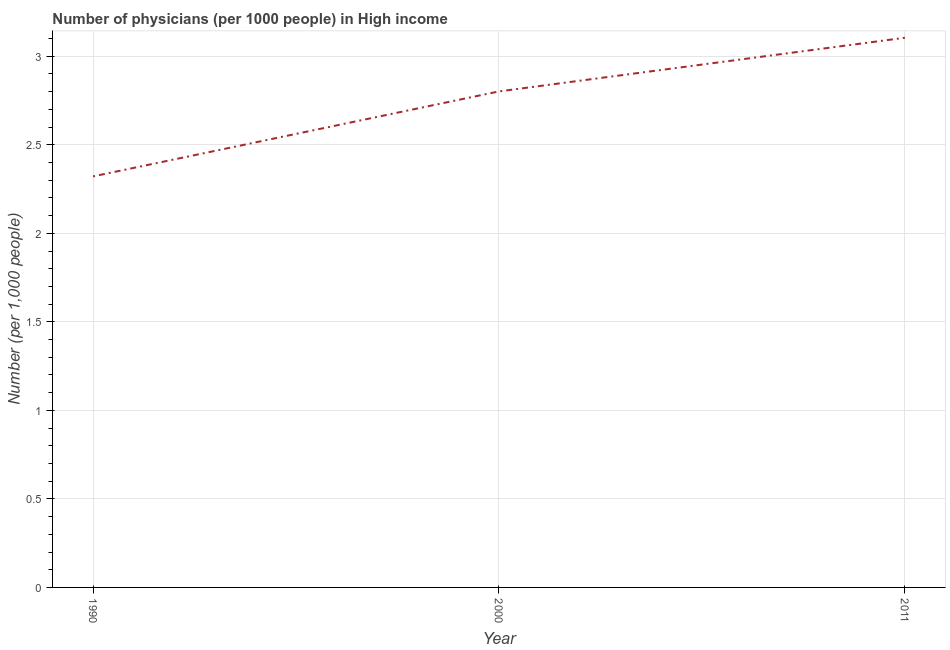What is the number of physicians in 1990?
Make the answer very short. 2.32. Across all years, what is the maximum number of physicians?
Ensure brevity in your answer.  3.1. Across all years, what is the minimum number of physicians?
Give a very brief answer. 2.32. In which year was the number of physicians maximum?
Your response must be concise. 2011. In which year was the number of physicians minimum?
Provide a succinct answer. 1990. What is the sum of the number of physicians?
Your answer should be very brief. 8.23. What is the difference between the number of physicians in 2000 and 2011?
Your answer should be compact. -0.3. What is the average number of physicians per year?
Offer a very short reply. 2.74. What is the median number of physicians?
Provide a short and direct response. 2.8. What is the ratio of the number of physicians in 1990 to that in 2011?
Give a very brief answer. 0.75. Is the difference between the number of physicians in 2000 and 2011 greater than the difference between any two years?
Your answer should be compact. No. What is the difference between the highest and the second highest number of physicians?
Keep it short and to the point. 0.3. What is the difference between the highest and the lowest number of physicians?
Offer a terse response. 0.78. How many lines are there?
Give a very brief answer. 1. What is the title of the graph?
Offer a very short reply. Number of physicians (per 1000 people) in High income. What is the label or title of the Y-axis?
Provide a short and direct response. Number (per 1,0 people). What is the Number (per 1,000 people) of 1990?
Keep it short and to the point. 2.32. What is the Number (per 1,000 people) in 2000?
Your answer should be very brief. 2.8. What is the Number (per 1,000 people) in 2011?
Offer a very short reply. 3.1. What is the difference between the Number (per 1,000 people) in 1990 and 2000?
Provide a succinct answer. -0.48. What is the difference between the Number (per 1,000 people) in 1990 and 2011?
Make the answer very short. -0.78. What is the difference between the Number (per 1,000 people) in 2000 and 2011?
Provide a short and direct response. -0.3. What is the ratio of the Number (per 1,000 people) in 1990 to that in 2000?
Give a very brief answer. 0.83. What is the ratio of the Number (per 1,000 people) in 1990 to that in 2011?
Give a very brief answer. 0.75. What is the ratio of the Number (per 1,000 people) in 2000 to that in 2011?
Ensure brevity in your answer.  0.9. 